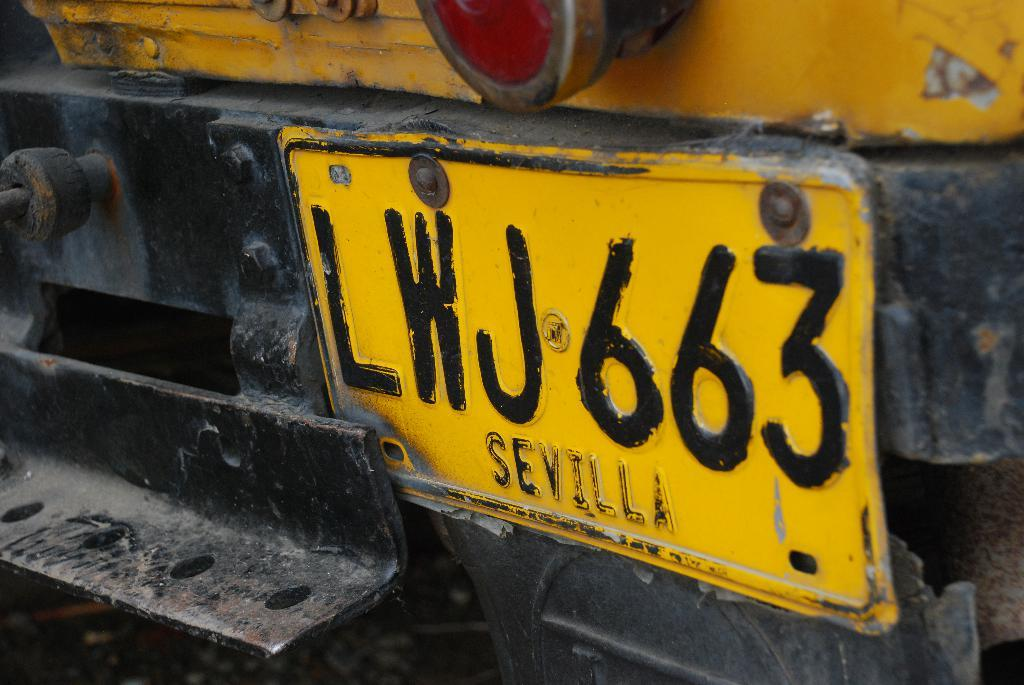<image>
Render a clear and concise summary of the photo. A license plate with SEVILLA across the bottom. 